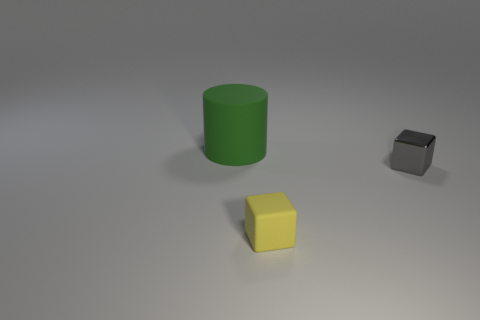Add 3 yellow shiny objects. How many objects exist? 6 Subtract all green matte objects. Subtract all yellow matte cubes. How many objects are left? 1 Add 3 tiny yellow matte objects. How many tiny yellow matte objects are left? 4 Add 1 small green matte objects. How many small green matte objects exist? 1 Subtract 0 purple cylinders. How many objects are left? 3 Subtract all cylinders. How many objects are left? 2 